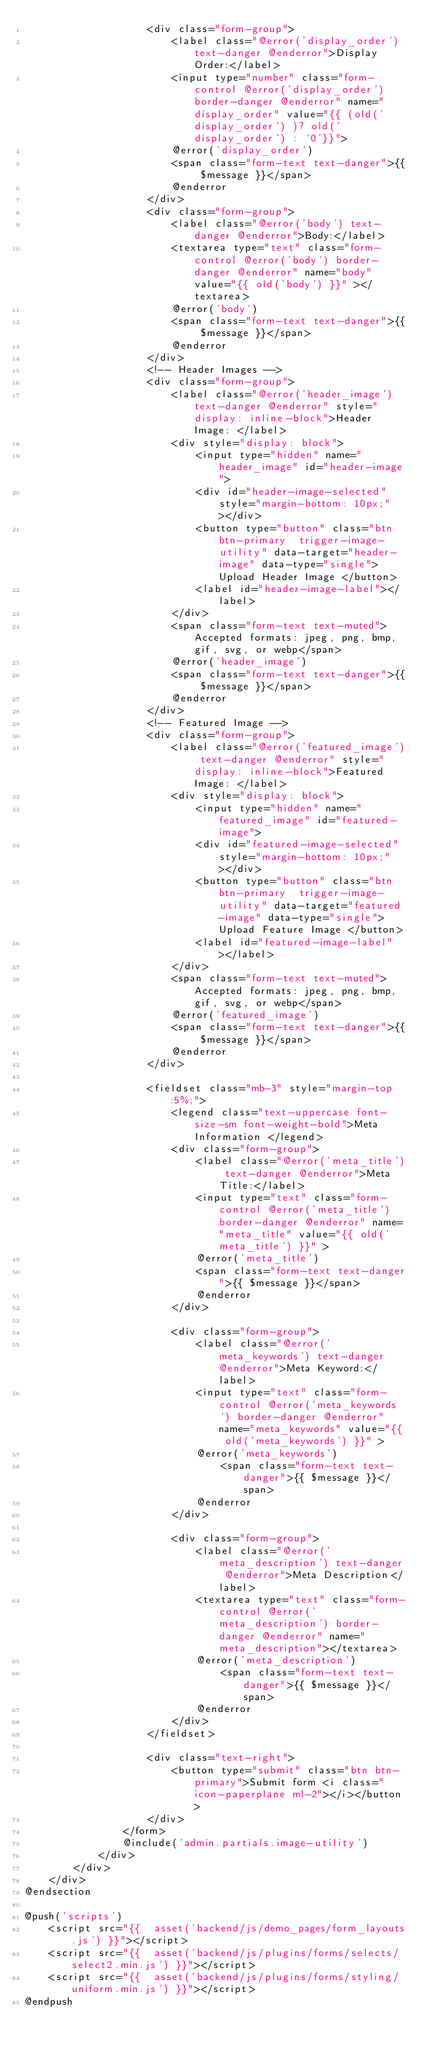Convert code to text. <code><loc_0><loc_0><loc_500><loc_500><_PHP_>                    <div class="form-group">
                        <label class="@error('display_order') text-danger @enderror">Display Order:</label>
                        <input type="number" class="form-control @error('display_order') border-danger @enderror" name="display_order" value="{{ (old('display_order') )? old('display_order') : '0'}}">
                        @error('display_order')
                        <span class="form-text text-danger">{{ $message }}</span>
                        @enderror
                    </div>
                    <div class="form-group">
                        <label class="@error('body') text-danger @enderror">Body:</label>
                        <textarea type="text" class="form-control @error('body') border-danger @enderror" name="body" value="{{ old('body') }}" ></textarea>
                        @error('body')
                        <span class="form-text text-danger">{{ $message }}</span>
                        @enderror
                    </div>
                    <!-- Header Images -->
                    <div class="form-group">
                        <label class="@error('header_image') text-danger @enderror" style="display: inline-block">Header Image: </label>
                        <div style="display: block">
                            <input type="hidden" name="header_image" id="header-image">
                            <div id="header-image-selected" style="margin-bottom: 10px;"></div>
                            <button type="button" class="btn btn-primary  trigger-image-utility" data-target="header-image" data-type="single">Upload Header Image </button>
                            <label id="header-image-label"></label>
                        </div>
                        <span class="form-text text-muted">Accepted formats: jpeg, png, bmp, gif, svg, or webp</span>
                        @error('header_image')
                        <span class="form-text text-danger">{{ $message }}</span>
                        @enderror
                    </div>
                    <!-- Featured Image -->
                    <div class="form-group">
                        <label class="@error('featured_image') text-danger @enderror" style="display: inline-block">Featured Image: </label>
                        <div style="display: block">
                            <input type="hidden" name="featured_image" id="featured-image">
                            <div id="featured-image-selected" style="margin-bottom: 10px;"></div>
                            <button type="button" class="btn btn-primary  trigger-image-utility" data-target="featured-image" data-type="single">Upload Feature Image </button>
                            <label id="featured-image-label"></label>
                        </div>
                        <span class="form-text text-muted">Accepted formats: jpeg, png, bmp, gif, svg, or webp</span>
                        @error('featured_image')
                        <span class="form-text text-danger">{{ $message }}</span>
                        @enderror
                    </div>

                    <fieldset class="mb-3" style="margin-top:5%;">
                        <legend class="text-uppercase font-size-sm font-weight-bold">Meta Information </legend>
                        <div class="form-group">
                            <label class="@error('meta_title') text-danger @enderror">Meta Title:</label>
                            <input type="text" class="form-control @error('meta_title') border-danger @enderror" name="meta_title" value="{{ old('meta_title') }}" >
                            @error('meta_title')
                            <span class="form-text text-danger">{{ $message }}</span>
                            @enderror
                        </div>

                        <div class="form-group">
                            <label class="@error('meta_keywords') text-danger @enderror">Meta Keyword:</label>
                            <input type="text" class="form-control @error('meta_keywords') border-danger @enderror" name="meta_keywords" value="{{ old('meta_keywords') }}" >
                            @error('meta_keywords')
                                <span class="form-text text-danger">{{ $message }}</span>
                            @enderror
                        </div>

                        <div class="form-group">
                            <label class="@error('meta_description') text-danger @enderror">Meta Description</label>
                            <textarea type="text" class="form-control @error('meta_description') border-danger @enderror" name="meta_description"></textarea>
                            @error('meta_description')
                                <span class="form-text text-danger">{{ $message }}</span>
                            @enderror
                        </div>
                    </fieldset>

                    <div class="text-right">
                        <button type="submit" class="btn btn-primary">Submit form <i class="icon-paperplane ml-2"></i></button>
                    </div>
                </form>
                @include('admin.partials.image-utility')
            </div>
        </div>
    </div>
@endsection

@push('scripts')
    <script src="{{  asset('backend/js/demo_pages/form_layouts.js') }}"></script>
    <script src="{{  asset('backend/js/plugins/forms/selects/select2.min.js') }}"></script>
    <script src="{{  asset('backend/js/plugins/forms/styling/uniform.min.js') }}"></script>
@endpush
</code> 